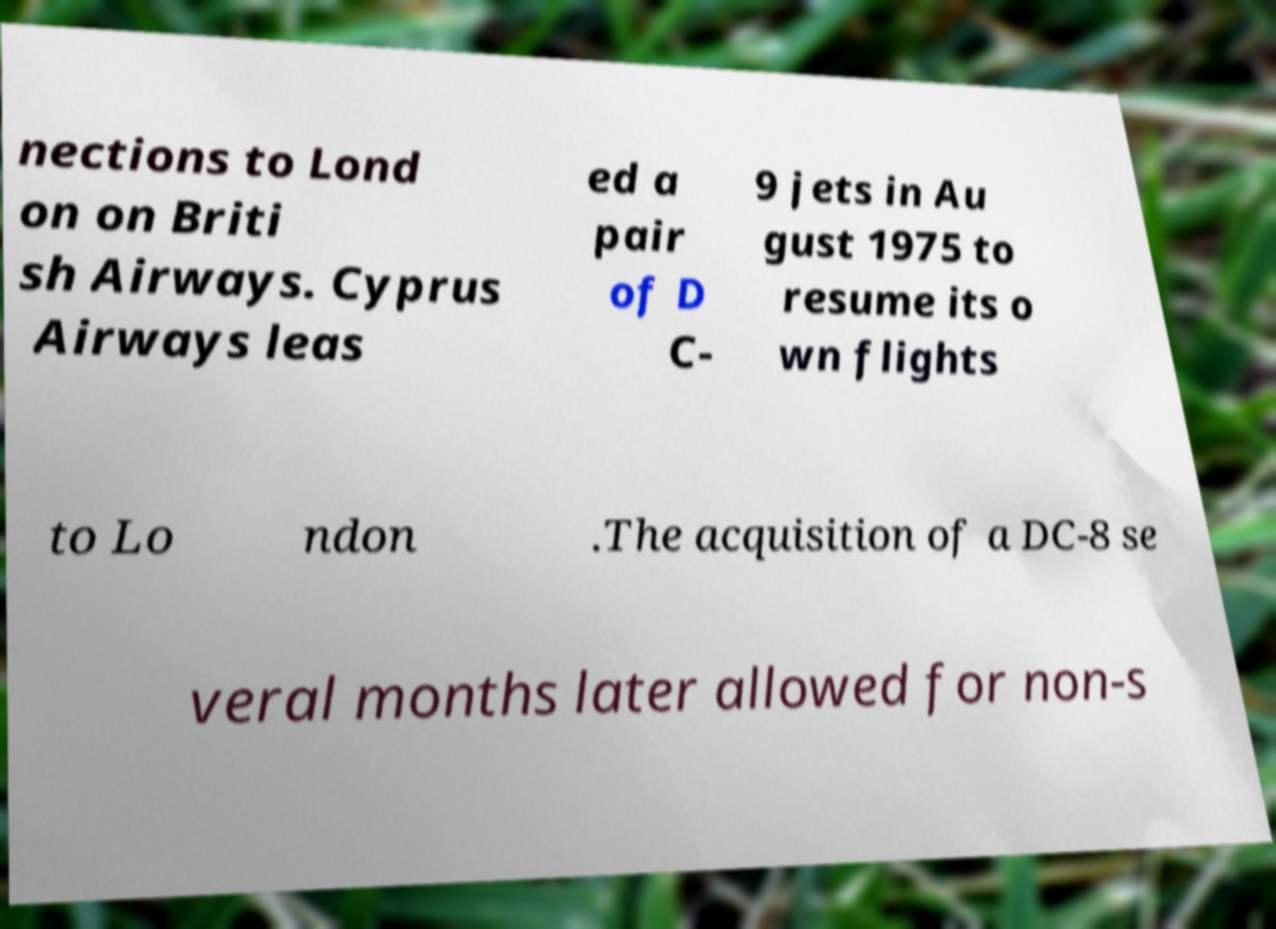Could you assist in decoding the text presented in this image and type it out clearly? nections to Lond on on Briti sh Airways. Cyprus Airways leas ed a pair of D C- 9 jets in Au gust 1975 to resume its o wn flights to Lo ndon .The acquisition of a DC-8 se veral months later allowed for non-s 